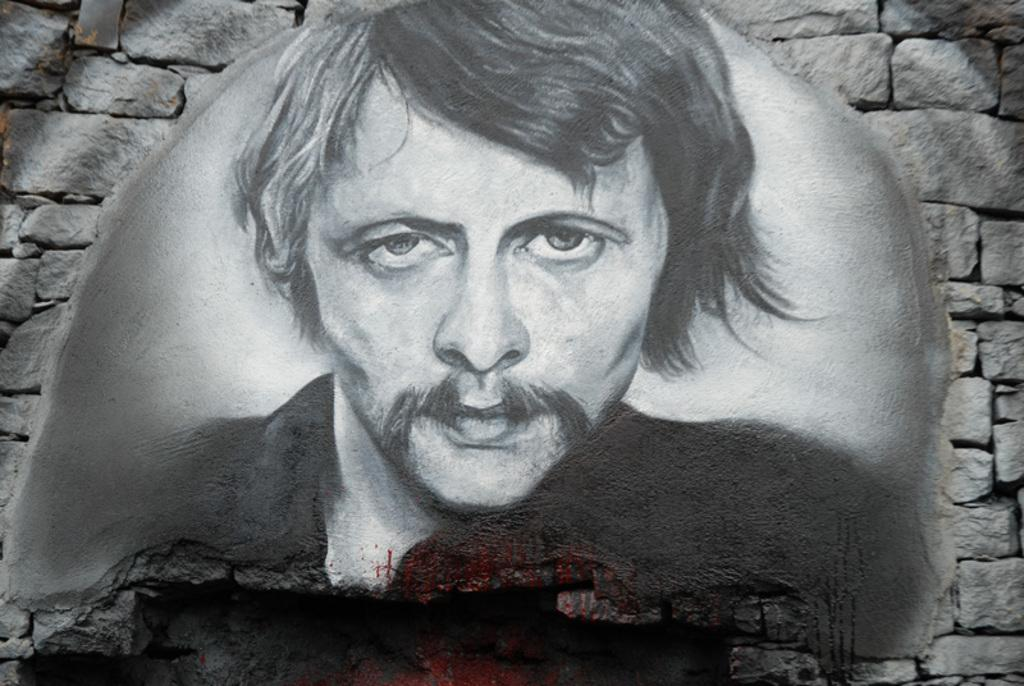What is the main subject of the painting in the image? The painting is of a man. Where is the painting located in the image? The painting is in the middle of the image. What type of structure surrounds the painting? There is a stone wall around the painting. How many crows are perched on the stone wall in the image? There are no crows present in the image; it only features a painting of a man surrounded by a stone wall. What type of military vehicle can be seen driving through the stone wall in the image? There is no military vehicle or any vehicle present in the image; it only features a painting of a man surrounded by a stone wall. 